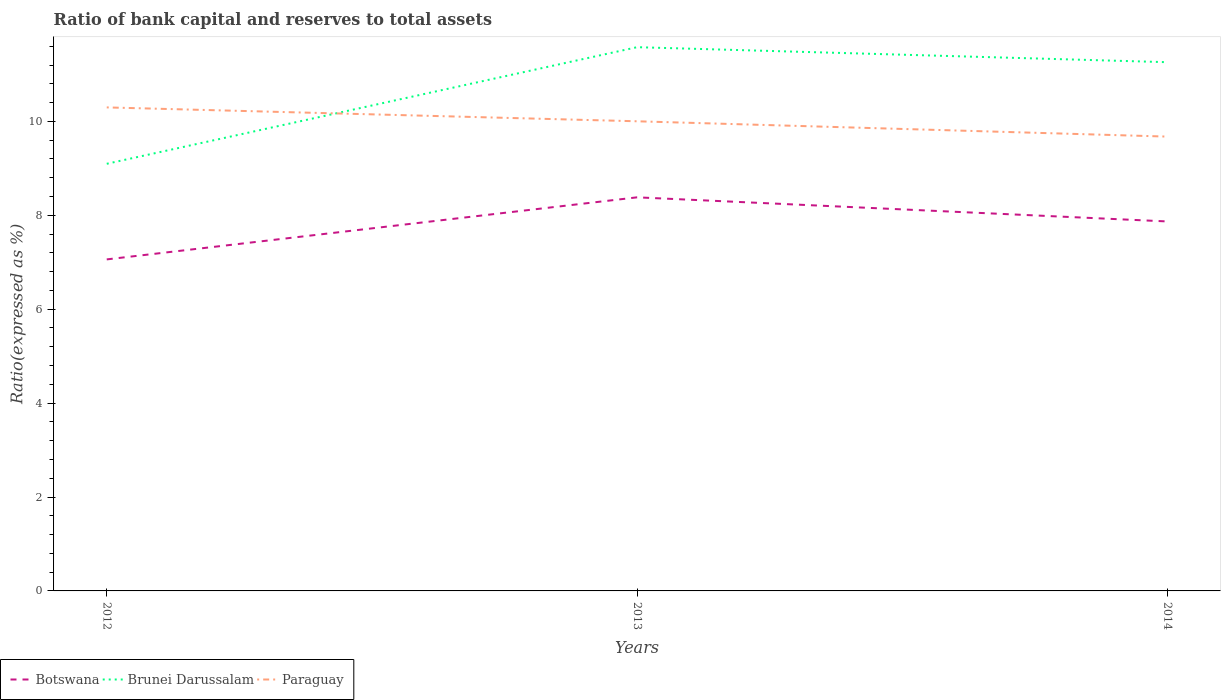Across all years, what is the maximum ratio of bank capital and reserves to total assets in Paraguay?
Provide a succinct answer. 9.68. In which year was the ratio of bank capital and reserves to total assets in Botswana maximum?
Make the answer very short. 2012. What is the total ratio of bank capital and reserves to total assets in Brunei Darussalam in the graph?
Your response must be concise. 0.32. What is the difference between the highest and the second highest ratio of bank capital and reserves to total assets in Brunei Darussalam?
Offer a very short reply. 2.48. Is the ratio of bank capital and reserves to total assets in Brunei Darussalam strictly greater than the ratio of bank capital and reserves to total assets in Botswana over the years?
Ensure brevity in your answer.  No. How many lines are there?
Provide a succinct answer. 3. How many years are there in the graph?
Provide a short and direct response. 3. What is the difference between two consecutive major ticks on the Y-axis?
Provide a short and direct response. 2. Are the values on the major ticks of Y-axis written in scientific E-notation?
Your answer should be very brief. No. Does the graph contain any zero values?
Your answer should be very brief. No. Does the graph contain grids?
Offer a very short reply. No. Where does the legend appear in the graph?
Keep it short and to the point. Bottom left. How many legend labels are there?
Provide a short and direct response. 3. How are the legend labels stacked?
Make the answer very short. Horizontal. What is the title of the graph?
Make the answer very short. Ratio of bank capital and reserves to total assets. What is the label or title of the X-axis?
Provide a succinct answer. Years. What is the label or title of the Y-axis?
Keep it short and to the point. Ratio(expressed as %). What is the Ratio(expressed as %) of Botswana in 2012?
Offer a very short reply. 7.06. What is the Ratio(expressed as %) in Brunei Darussalam in 2012?
Your answer should be very brief. 9.1. What is the Ratio(expressed as %) in Paraguay in 2012?
Your response must be concise. 10.3. What is the Ratio(expressed as %) in Botswana in 2013?
Ensure brevity in your answer.  8.38. What is the Ratio(expressed as %) in Brunei Darussalam in 2013?
Offer a very short reply. 11.58. What is the Ratio(expressed as %) in Paraguay in 2013?
Your response must be concise. 10. What is the Ratio(expressed as %) of Botswana in 2014?
Provide a short and direct response. 7.87. What is the Ratio(expressed as %) in Brunei Darussalam in 2014?
Your answer should be compact. 11.26. What is the Ratio(expressed as %) of Paraguay in 2014?
Keep it short and to the point. 9.68. Across all years, what is the maximum Ratio(expressed as %) of Botswana?
Make the answer very short. 8.38. Across all years, what is the maximum Ratio(expressed as %) in Brunei Darussalam?
Offer a terse response. 11.58. Across all years, what is the maximum Ratio(expressed as %) in Paraguay?
Your answer should be very brief. 10.3. Across all years, what is the minimum Ratio(expressed as %) of Botswana?
Your answer should be compact. 7.06. Across all years, what is the minimum Ratio(expressed as %) of Brunei Darussalam?
Your answer should be very brief. 9.1. Across all years, what is the minimum Ratio(expressed as %) in Paraguay?
Offer a terse response. 9.68. What is the total Ratio(expressed as %) of Botswana in the graph?
Give a very brief answer. 23.31. What is the total Ratio(expressed as %) in Brunei Darussalam in the graph?
Ensure brevity in your answer.  31.94. What is the total Ratio(expressed as %) of Paraguay in the graph?
Your response must be concise. 29.98. What is the difference between the Ratio(expressed as %) in Botswana in 2012 and that in 2013?
Your response must be concise. -1.32. What is the difference between the Ratio(expressed as %) in Brunei Darussalam in 2012 and that in 2013?
Your response must be concise. -2.48. What is the difference between the Ratio(expressed as %) of Paraguay in 2012 and that in 2013?
Your answer should be compact. 0.3. What is the difference between the Ratio(expressed as %) in Botswana in 2012 and that in 2014?
Offer a very short reply. -0.81. What is the difference between the Ratio(expressed as %) of Brunei Darussalam in 2012 and that in 2014?
Give a very brief answer. -2.16. What is the difference between the Ratio(expressed as %) of Paraguay in 2012 and that in 2014?
Ensure brevity in your answer.  0.62. What is the difference between the Ratio(expressed as %) in Botswana in 2013 and that in 2014?
Provide a succinct answer. 0.51. What is the difference between the Ratio(expressed as %) of Brunei Darussalam in 2013 and that in 2014?
Your answer should be compact. 0.32. What is the difference between the Ratio(expressed as %) of Paraguay in 2013 and that in 2014?
Provide a short and direct response. 0.33. What is the difference between the Ratio(expressed as %) of Botswana in 2012 and the Ratio(expressed as %) of Brunei Darussalam in 2013?
Provide a short and direct response. -4.52. What is the difference between the Ratio(expressed as %) in Botswana in 2012 and the Ratio(expressed as %) in Paraguay in 2013?
Your answer should be compact. -2.94. What is the difference between the Ratio(expressed as %) of Brunei Darussalam in 2012 and the Ratio(expressed as %) of Paraguay in 2013?
Your response must be concise. -0.91. What is the difference between the Ratio(expressed as %) in Botswana in 2012 and the Ratio(expressed as %) in Brunei Darussalam in 2014?
Offer a very short reply. -4.2. What is the difference between the Ratio(expressed as %) of Botswana in 2012 and the Ratio(expressed as %) of Paraguay in 2014?
Keep it short and to the point. -2.62. What is the difference between the Ratio(expressed as %) in Brunei Darussalam in 2012 and the Ratio(expressed as %) in Paraguay in 2014?
Your answer should be compact. -0.58. What is the difference between the Ratio(expressed as %) in Botswana in 2013 and the Ratio(expressed as %) in Brunei Darussalam in 2014?
Your answer should be compact. -2.88. What is the difference between the Ratio(expressed as %) in Botswana in 2013 and the Ratio(expressed as %) in Paraguay in 2014?
Your answer should be compact. -1.29. What is the difference between the Ratio(expressed as %) of Brunei Darussalam in 2013 and the Ratio(expressed as %) of Paraguay in 2014?
Give a very brief answer. 1.9. What is the average Ratio(expressed as %) in Botswana per year?
Keep it short and to the point. 7.77. What is the average Ratio(expressed as %) of Brunei Darussalam per year?
Keep it short and to the point. 10.65. What is the average Ratio(expressed as %) in Paraguay per year?
Your response must be concise. 9.99. In the year 2012, what is the difference between the Ratio(expressed as %) in Botswana and Ratio(expressed as %) in Brunei Darussalam?
Offer a very short reply. -2.04. In the year 2012, what is the difference between the Ratio(expressed as %) of Botswana and Ratio(expressed as %) of Paraguay?
Your answer should be very brief. -3.24. In the year 2012, what is the difference between the Ratio(expressed as %) in Brunei Darussalam and Ratio(expressed as %) in Paraguay?
Give a very brief answer. -1.2. In the year 2013, what is the difference between the Ratio(expressed as %) of Botswana and Ratio(expressed as %) of Brunei Darussalam?
Provide a short and direct response. -3.2. In the year 2013, what is the difference between the Ratio(expressed as %) of Botswana and Ratio(expressed as %) of Paraguay?
Ensure brevity in your answer.  -1.62. In the year 2013, what is the difference between the Ratio(expressed as %) of Brunei Darussalam and Ratio(expressed as %) of Paraguay?
Offer a very short reply. 1.58. In the year 2014, what is the difference between the Ratio(expressed as %) of Botswana and Ratio(expressed as %) of Brunei Darussalam?
Make the answer very short. -3.39. In the year 2014, what is the difference between the Ratio(expressed as %) of Botswana and Ratio(expressed as %) of Paraguay?
Keep it short and to the point. -1.81. In the year 2014, what is the difference between the Ratio(expressed as %) of Brunei Darussalam and Ratio(expressed as %) of Paraguay?
Ensure brevity in your answer.  1.58. What is the ratio of the Ratio(expressed as %) in Botswana in 2012 to that in 2013?
Offer a terse response. 0.84. What is the ratio of the Ratio(expressed as %) of Brunei Darussalam in 2012 to that in 2013?
Provide a short and direct response. 0.79. What is the ratio of the Ratio(expressed as %) in Paraguay in 2012 to that in 2013?
Offer a very short reply. 1.03. What is the ratio of the Ratio(expressed as %) in Botswana in 2012 to that in 2014?
Your response must be concise. 0.9. What is the ratio of the Ratio(expressed as %) in Brunei Darussalam in 2012 to that in 2014?
Ensure brevity in your answer.  0.81. What is the ratio of the Ratio(expressed as %) in Paraguay in 2012 to that in 2014?
Provide a short and direct response. 1.06. What is the ratio of the Ratio(expressed as %) of Botswana in 2013 to that in 2014?
Make the answer very short. 1.07. What is the ratio of the Ratio(expressed as %) of Brunei Darussalam in 2013 to that in 2014?
Offer a very short reply. 1.03. What is the ratio of the Ratio(expressed as %) in Paraguay in 2013 to that in 2014?
Provide a succinct answer. 1.03. What is the difference between the highest and the second highest Ratio(expressed as %) of Botswana?
Give a very brief answer. 0.51. What is the difference between the highest and the second highest Ratio(expressed as %) in Brunei Darussalam?
Keep it short and to the point. 0.32. What is the difference between the highest and the second highest Ratio(expressed as %) of Paraguay?
Provide a short and direct response. 0.3. What is the difference between the highest and the lowest Ratio(expressed as %) of Botswana?
Ensure brevity in your answer.  1.32. What is the difference between the highest and the lowest Ratio(expressed as %) of Brunei Darussalam?
Provide a short and direct response. 2.48. What is the difference between the highest and the lowest Ratio(expressed as %) in Paraguay?
Keep it short and to the point. 0.62. 